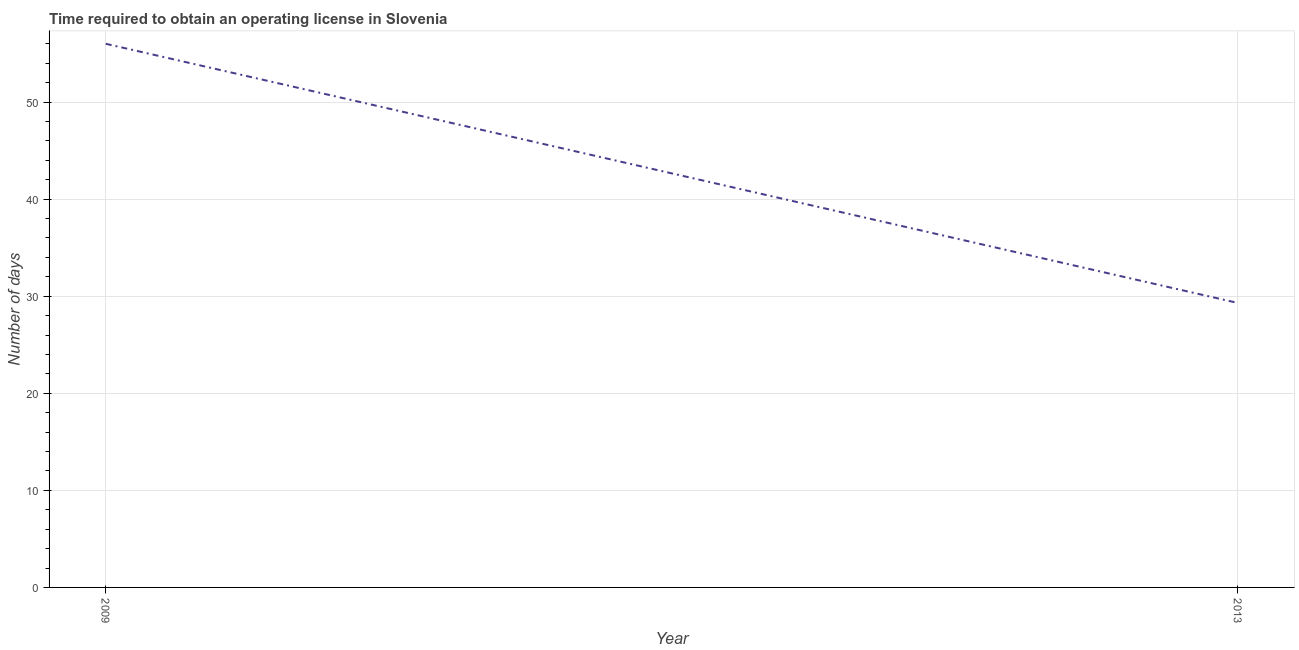What is the number of days to obtain operating license in 2009?
Your answer should be very brief. 56. Across all years, what is the maximum number of days to obtain operating license?
Your response must be concise. 56. Across all years, what is the minimum number of days to obtain operating license?
Offer a terse response. 29.3. In which year was the number of days to obtain operating license minimum?
Your answer should be very brief. 2013. What is the sum of the number of days to obtain operating license?
Give a very brief answer. 85.3. What is the difference between the number of days to obtain operating license in 2009 and 2013?
Your answer should be compact. 26.7. What is the average number of days to obtain operating license per year?
Make the answer very short. 42.65. What is the median number of days to obtain operating license?
Provide a succinct answer. 42.65. Do a majority of the years between 2013 and 2009 (inclusive) have number of days to obtain operating license greater than 52 days?
Your answer should be compact. No. What is the ratio of the number of days to obtain operating license in 2009 to that in 2013?
Your answer should be compact. 1.91. Is the number of days to obtain operating license in 2009 less than that in 2013?
Offer a terse response. No. How many years are there in the graph?
Your answer should be compact. 2. What is the title of the graph?
Give a very brief answer. Time required to obtain an operating license in Slovenia. What is the label or title of the X-axis?
Keep it short and to the point. Year. What is the label or title of the Y-axis?
Make the answer very short. Number of days. What is the Number of days of 2009?
Make the answer very short. 56. What is the Number of days of 2013?
Keep it short and to the point. 29.3. What is the difference between the Number of days in 2009 and 2013?
Offer a very short reply. 26.7. What is the ratio of the Number of days in 2009 to that in 2013?
Offer a very short reply. 1.91. 